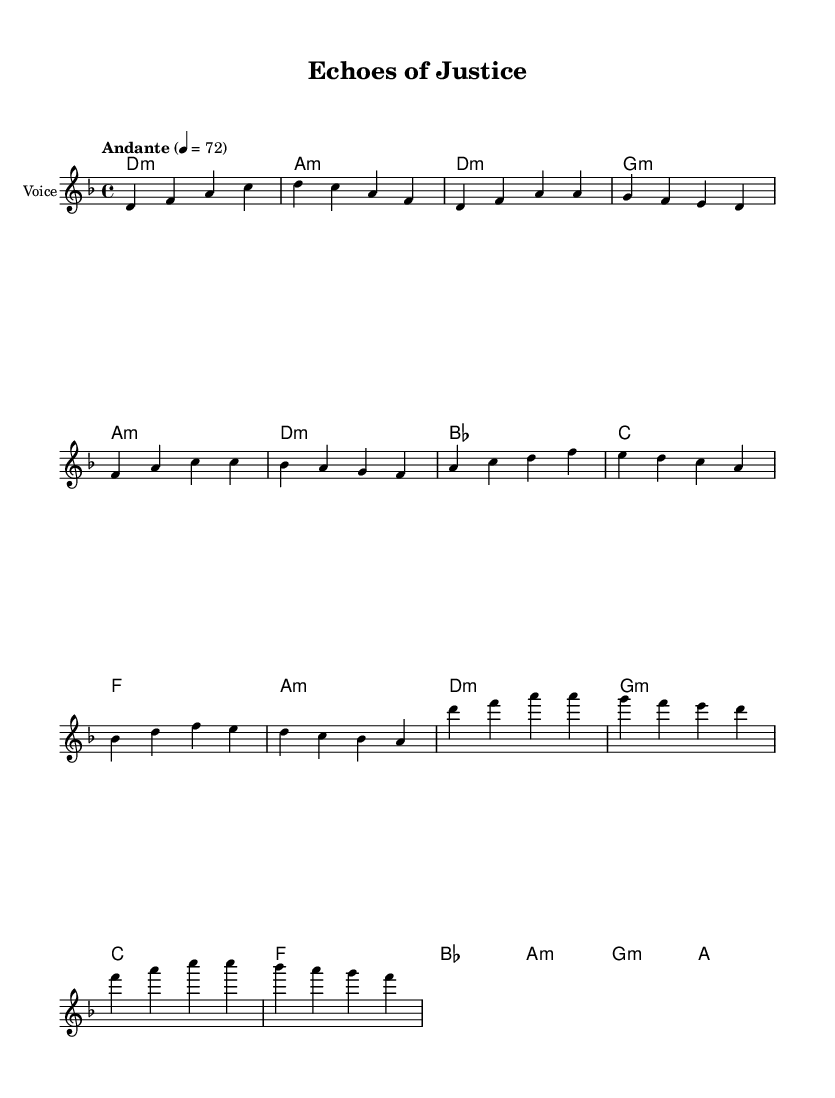What is the key signature of this music? The key signature is D minor, which has one flat (B flat). This is identifiable from the beginning of the piece, where the key is indicated.
Answer: D minor What is the time signature of the piece? The time signature is four-four, shown at the beginning of the score where it states "4/4". This indicates four beats in each measure and a quarter note gets one beat.
Answer: four-four What is the tempo marking for the music? The tempo marking is "Andante," which suggests a moderate walking pace. This is indicated in the tempo section situated at the start of the sheet music.
Answer: Andante How many measures are there in the chorus section? There are eight measures in the chorus section. By counting the individual measures in the chorus part of the music, we can identify the total.
Answer: eight What is the harmonic pattern in the pre-chorus? The harmonic pattern in the pre-chorus is B flat, C, F, A minor. This can be derived by looking at the chord symbols printed below the melody for that part.
Answer: B flat, C, F, A minor Identify the highest note in the melody line. The highest note in the melody line is D, which can be determined by reviewing the melody notes and identifying the maximum pitch in the recorded notes.
Answer: D What K-Pop characteristic is reflected in the lyric structure of this piece? The song features emotive expression which is a hallmark of K-Pop ballads, typically evident in the lyrical themes of love or struggle, combined with melodic grace. The emotional appeal can be inferred from the lyrical and musical structure, showcasing K-Pop's focus on sentimentality.
Answer: emotive expression 